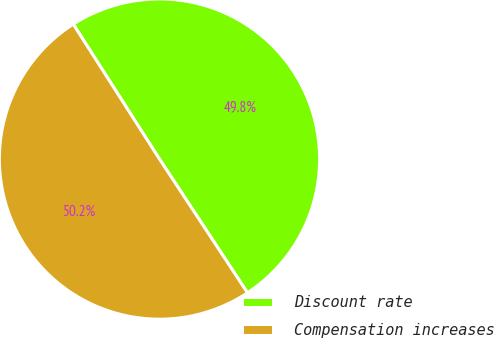<chart> <loc_0><loc_0><loc_500><loc_500><pie_chart><fcel>Discount rate<fcel>Compensation increases<nl><fcel>49.79%<fcel>50.21%<nl></chart> 